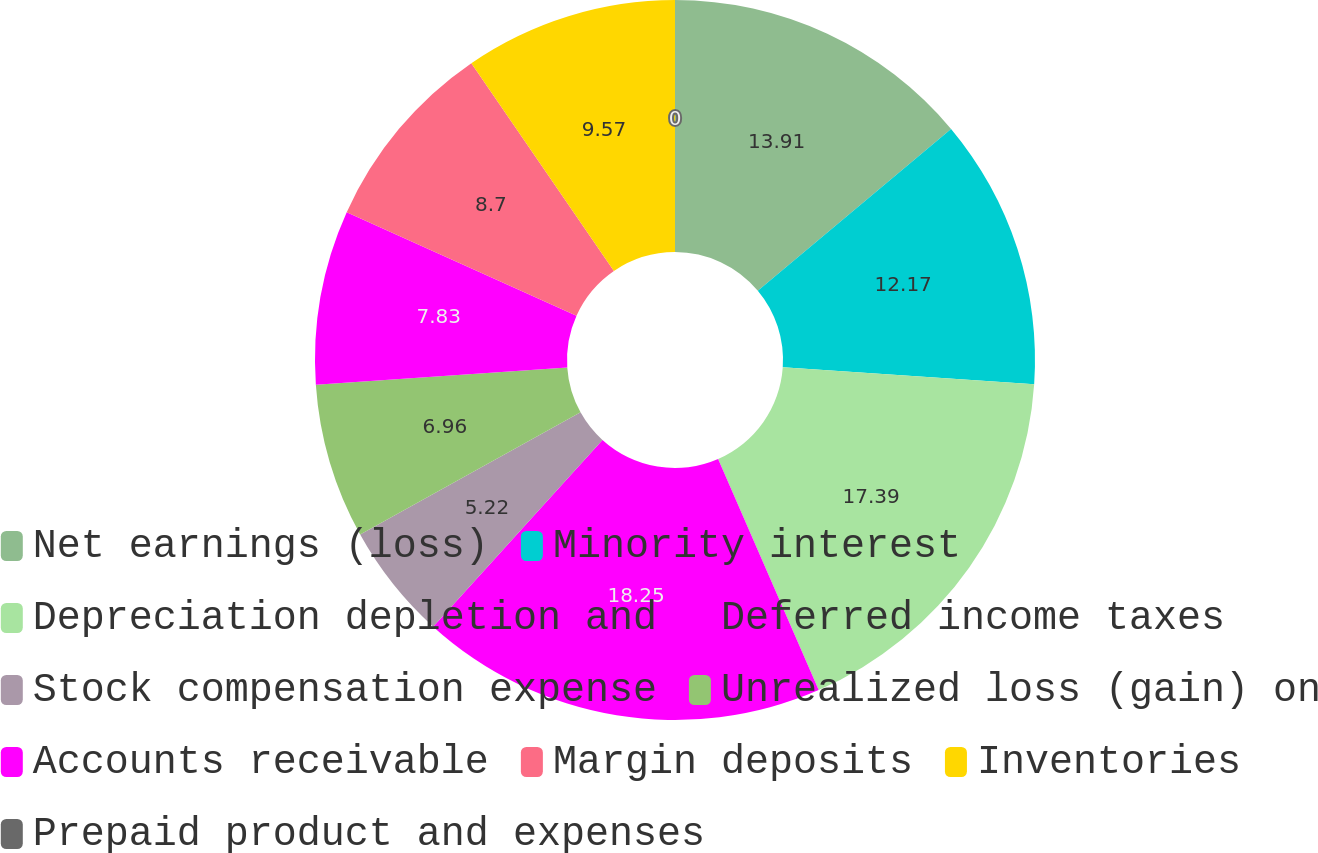<chart> <loc_0><loc_0><loc_500><loc_500><pie_chart><fcel>Net earnings (loss)<fcel>Minority interest<fcel>Depreciation depletion and<fcel>Deferred income taxes<fcel>Stock compensation expense<fcel>Unrealized loss (gain) on<fcel>Accounts receivable<fcel>Margin deposits<fcel>Inventories<fcel>Prepaid product and expenses<nl><fcel>13.91%<fcel>12.17%<fcel>17.39%<fcel>18.26%<fcel>5.22%<fcel>6.96%<fcel>7.83%<fcel>8.7%<fcel>9.57%<fcel>0.0%<nl></chart> 